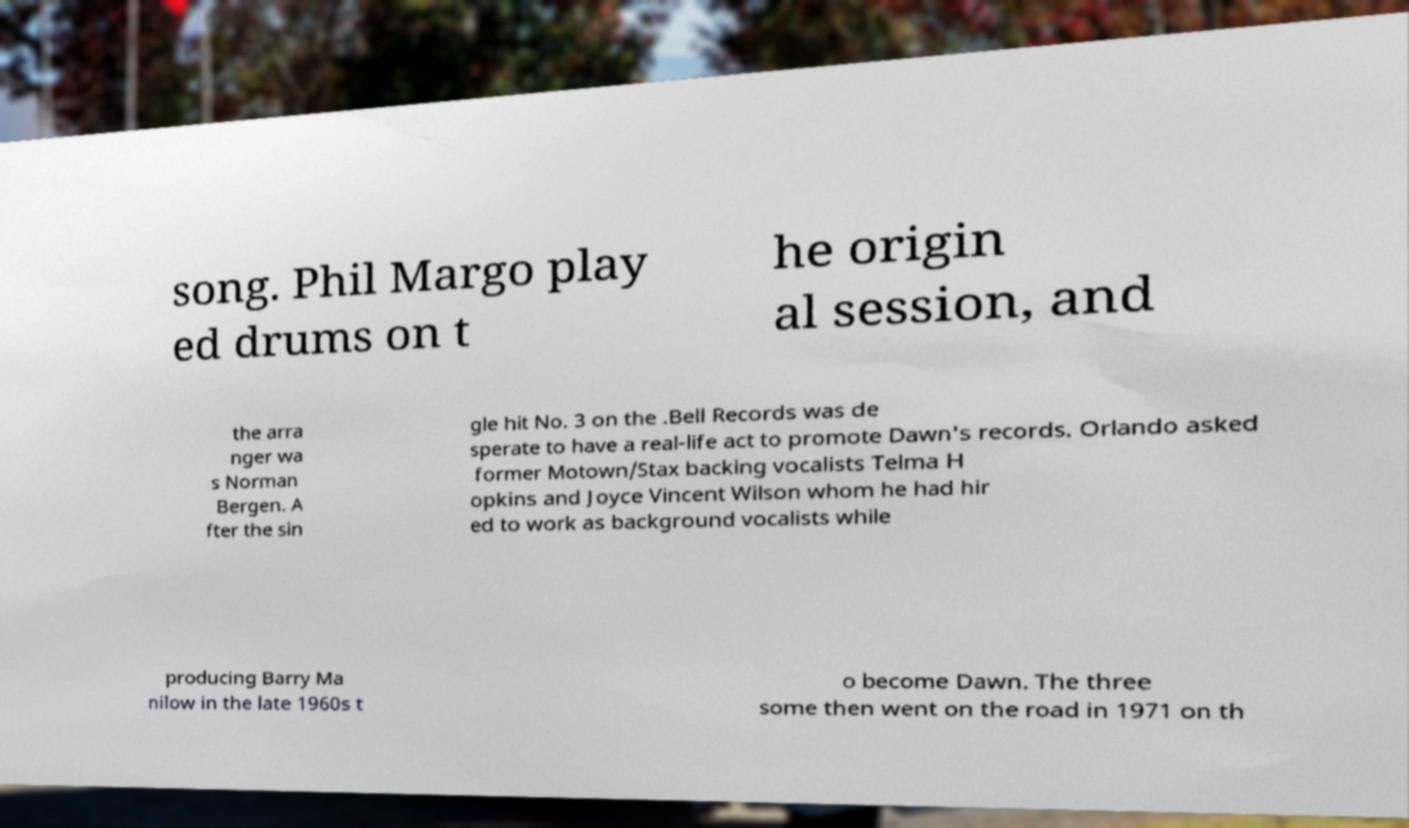For documentation purposes, I need the text within this image transcribed. Could you provide that? song. Phil Margo play ed drums on t he origin al session, and the arra nger wa s Norman Bergen. A fter the sin gle hit No. 3 on the .Bell Records was de sperate to have a real-life act to promote Dawn's records. Orlando asked former Motown/Stax backing vocalists Telma H opkins and Joyce Vincent Wilson whom he had hir ed to work as background vocalists while producing Barry Ma nilow in the late 1960s t o become Dawn. The three some then went on the road in 1971 on th 